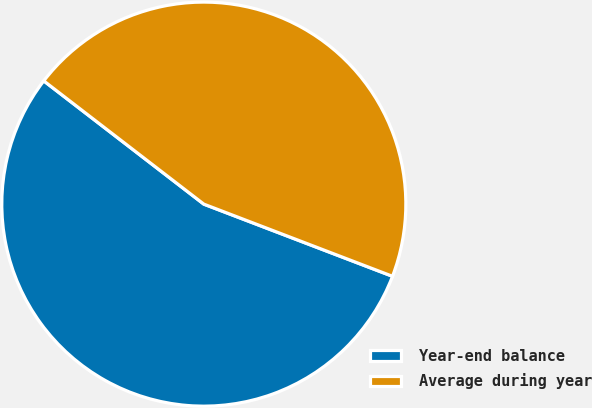Convert chart. <chart><loc_0><loc_0><loc_500><loc_500><pie_chart><fcel>Year-end balance<fcel>Average during year<nl><fcel>54.63%<fcel>45.37%<nl></chart> 